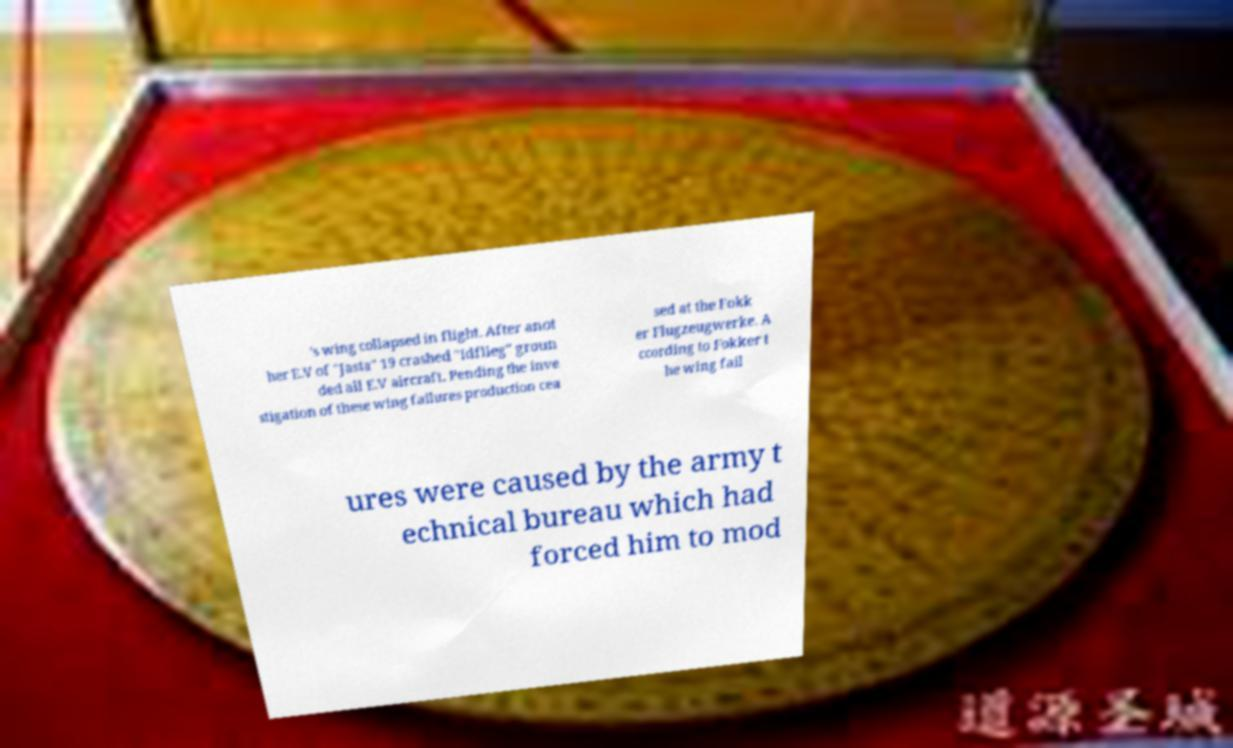What messages or text are displayed in this image? I need them in a readable, typed format. 's wing collapsed in flight. After anot her E.V of "Jasta" 19 crashed "Idflieg" groun ded all E.V aircraft. Pending the inve stigation of these wing failures production cea sed at the Fokk er Flugzeugwerke. A ccording to Fokker t he wing fail ures were caused by the army t echnical bureau which had forced him to mod 